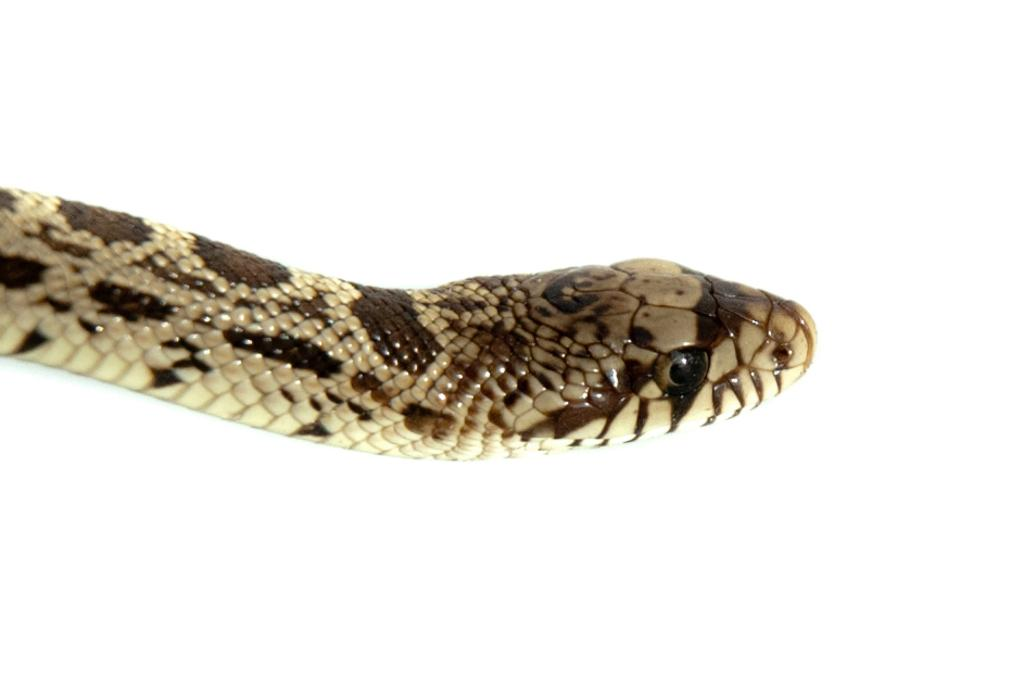What is the main subject of the image? There is a snake in the center of the image. What color is the background of the image? The background of the image is white in color. How many cards are being held by the snake in the image? There are no cards present in the image; it features a snake on a white background. What type of cloth is covering the snake in the image? There is no cloth covering the snake in the image; it is visible on a white background. 